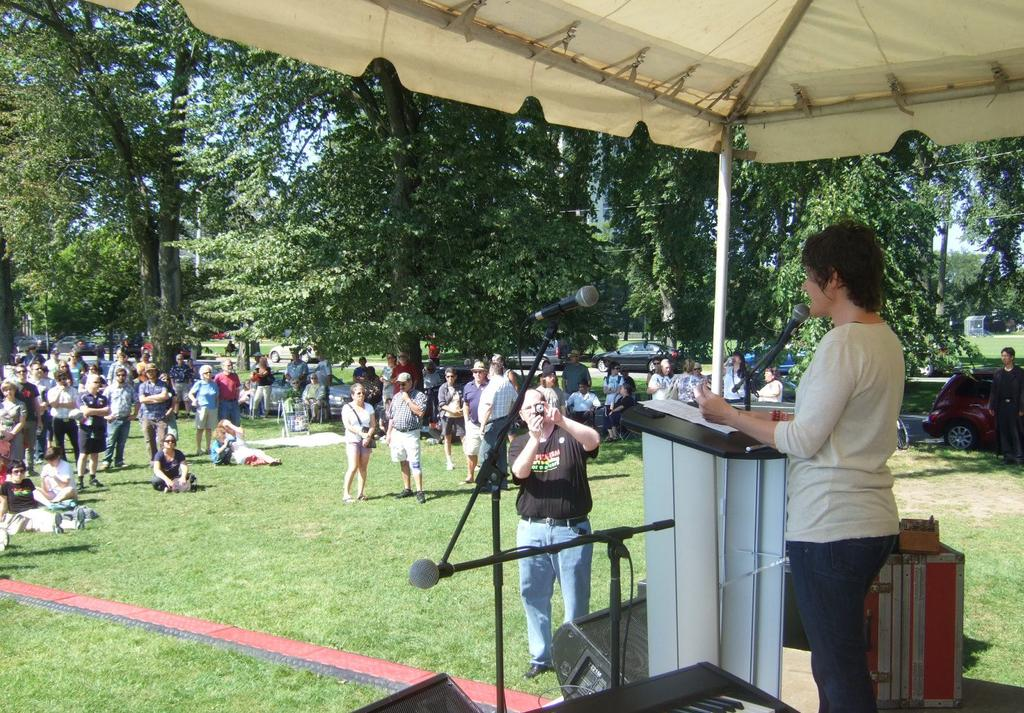What is the main subject of the image? There is a person standing in the image. What is the person doing in the image? The person is standing in front of a microphone. Are there any other people in the image? Yes, there are other persons standing in the background of the image. What can be seen in the background of the image? There are trees with green color and the sky is blue in color in the background of the image. How much does the giraffe cost in the image? There is no giraffe present in the image, so it is not possible to determine its cost. 